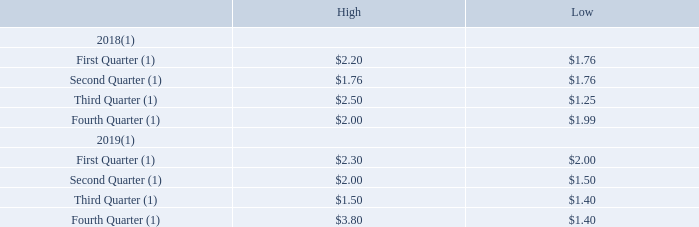Item 5. Market for Registrant’s Common Equity, Related Stockholder Matters and Issuer Purchases of Equity Securities.
Market information
Our common stock is currently available for trading in the over-the-counter market and is quoted on the OTCQB under the symbol “PTIX.” There has been very limited market for our common stock and trading volume has been negligible. There is no guarantee that an active trading market will develop in our common stock
Trades in our common stock may be subject to Rule 15g-9 of the Exchange Act, which imposes requirements on broker/dealers who sell securities subject to the rule
to persons other than established customers and accredited investors. For transactions covered by the rule, broker/dealers must make a special suitability determination for
purchasers of the securities and receive the purchaser’s written agreement to the transaction before the sale.
The SEC also has rules that regulate broker/dealer practices in connection with transactions in “penny stocks.” Penny stocks generally are equity securities with a
price of less than $5.00 (other than securities listed on certain national exchanges, provided that the current price and volume information with respect to transactions in that
security is provided by the applicable exchange or system). The penny stock rules require a broker/dealer, before effecting a transaction in a penny stock not otherwise exempt
from the rules, to deliver a standardized risk disclosure document prepared by the SEC that provides information about penny stocks and the nature and level of risks in the
penny stock market. The broker/dealer also must provide the customer with current bid and offer quotations for the penny stock, the compensation of the broker/dealer and its
salesperson in the transaction, and monthly account statements showing the market value of each penny stock held in the customer’s account. The bid and offer quotations,
and the broker/dealer and salesperson compensation information, must be given to the customer orally or in writing before effecting the transaction, and must be given to the customer in writing before or with the customer’s confirmation. These disclosure requirements may have the effect of reducing the level of trading activity in the secondary market for shares of our common stock. As a result of these rules, investors may find it difficult to sell their shares.
Our common stock was quoted on the OTC Pink under the symbol “ATRN” prior to July 27, 2016 and then under the symbol “PTIX” between July 27, 2016 and
October 16, 2016. Commencing on October 17, 2016, our common stock is quoted in the OTCQB under the symbol “PTIX”. The following table sets forth, for the periods
indicated and as reported on the OTC Markets, the high and low bid prices for our common stock. Such quotations reflect inter-dealer prices, without retail mark-up, markdown
or commission and may not necessarily represent actual transactions.
(1) The high and low bid prices for this quarter were reported by the OTCQB marketplace. There was negligible trading volume during this period.
How did the company obtain the high and low bid prices for each quarter? Reported by the otcqb marketplace. What is the company's common stock traded as on the OTCQB? Ptix. What was symbol of the company's common stock quoted on the OTC Pink quoted as prior to July 27, 2016? Atrn. What is the difference between the highest and lowest bid price in 2018? 2.50 - 1.25 
Answer: 1.25. What is the difference between the highest and lowest bid price in 2019? 3.80 - 1.40 
Answer: 2.4. What is the low bid price in the second quarter of 2019 as a percentage of the high bid price in the same period?
Answer scale should be: percent. 1.5/2 
Answer: 75. 